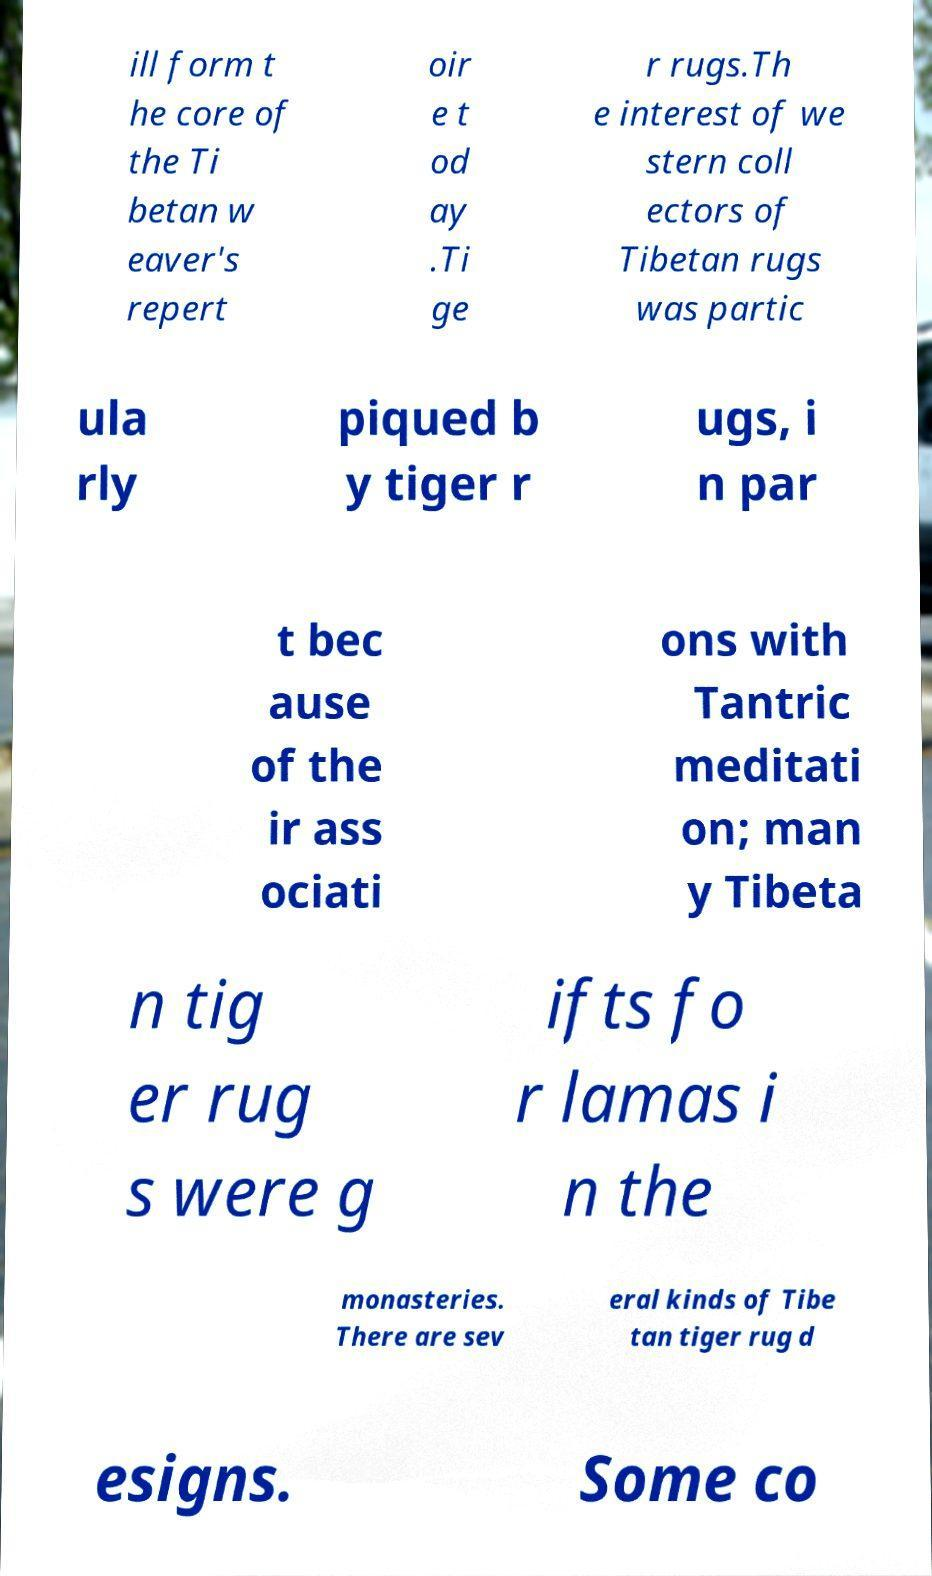Can you accurately transcribe the text from the provided image for me? ill form t he core of the Ti betan w eaver's repert oir e t od ay .Ti ge r rugs.Th e interest of we stern coll ectors of Tibetan rugs was partic ula rly piqued b y tiger r ugs, i n par t bec ause of the ir ass ociati ons with Tantric meditati on; man y Tibeta n tig er rug s were g ifts fo r lamas i n the monasteries. There are sev eral kinds of Tibe tan tiger rug d esigns. Some co 